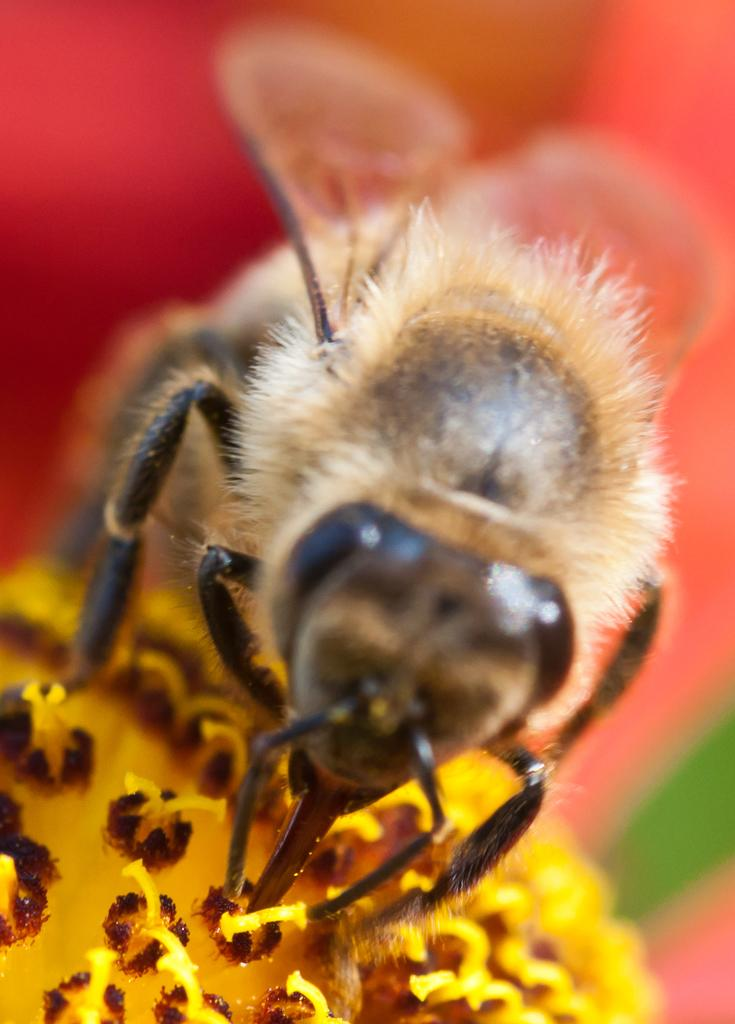What is the main subject of the image? There is an insect in the image. Where is the insect located? The insect is on a flower. Can you describe the background of the image? The background of the image is blurred. What type of transport can be seen in the image? There is no transport visible in the image; it features an insect on a flower with a blurred background. How many cubs are present in the image? There are no cubs present in the image; it features an insect on a flower with a blurred background. 